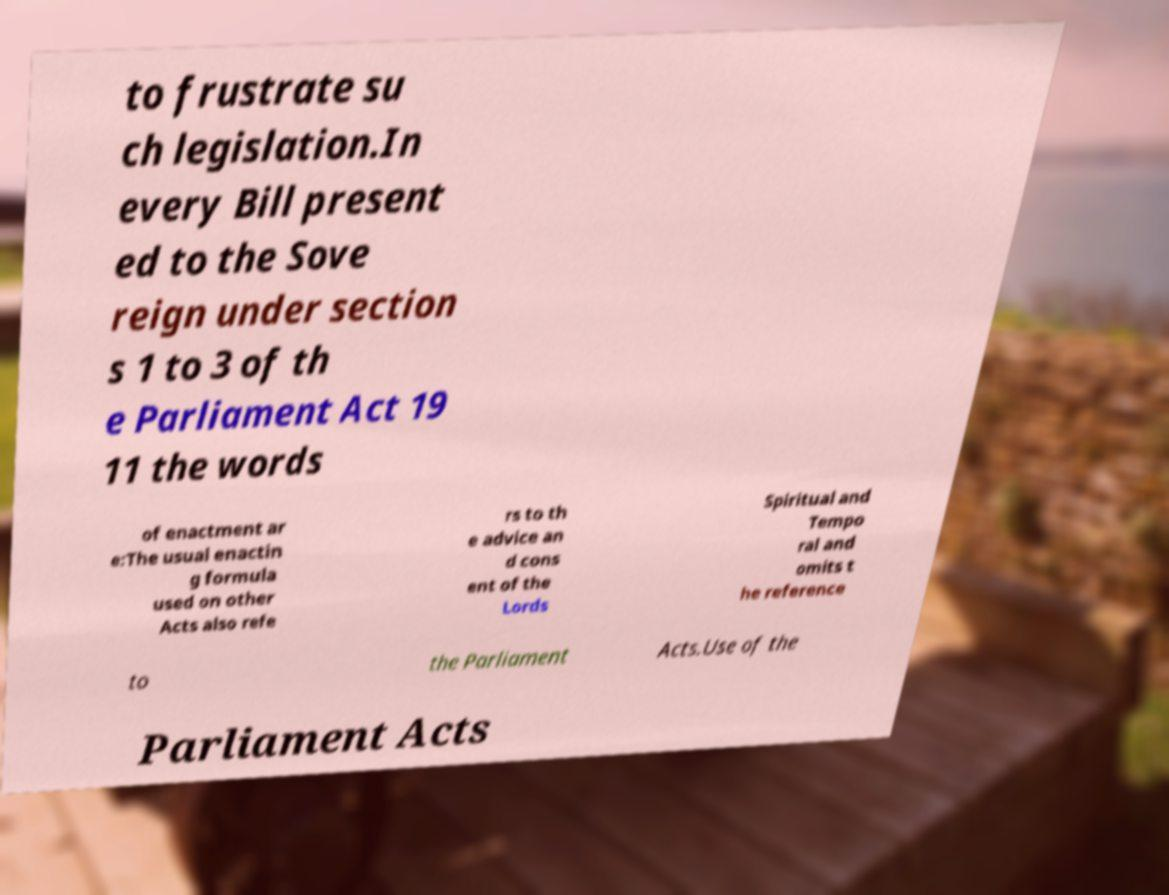Please identify and transcribe the text found in this image. to frustrate su ch legislation.In every Bill present ed to the Sove reign under section s 1 to 3 of th e Parliament Act 19 11 the words of enactment ar e:The usual enactin g formula used on other Acts also refe rs to th e advice an d cons ent of the Lords Spiritual and Tempo ral and omits t he reference to the Parliament Acts.Use of the Parliament Acts 